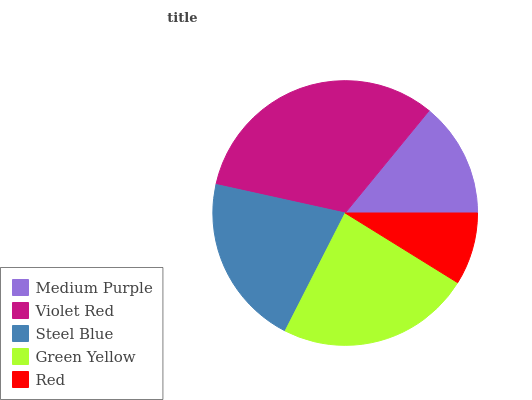Is Red the minimum?
Answer yes or no. Yes. Is Violet Red the maximum?
Answer yes or no. Yes. Is Steel Blue the minimum?
Answer yes or no. No. Is Steel Blue the maximum?
Answer yes or no. No. Is Violet Red greater than Steel Blue?
Answer yes or no. Yes. Is Steel Blue less than Violet Red?
Answer yes or no. Yes. Is Steel Blue greater than Violet Red?
Answer yes or no. No. Is Violet Red less than Steel Blue?
Answer yes or no. No. Is Steel Blue the high median?
Answer yes or no. Yes. Is Steel Blue the low median?
Answer yes or no. Yes. Is Green Yellow the high median?
Answer yes or no. No. Is Violet Red the low median?
Answer yes or no. No. 